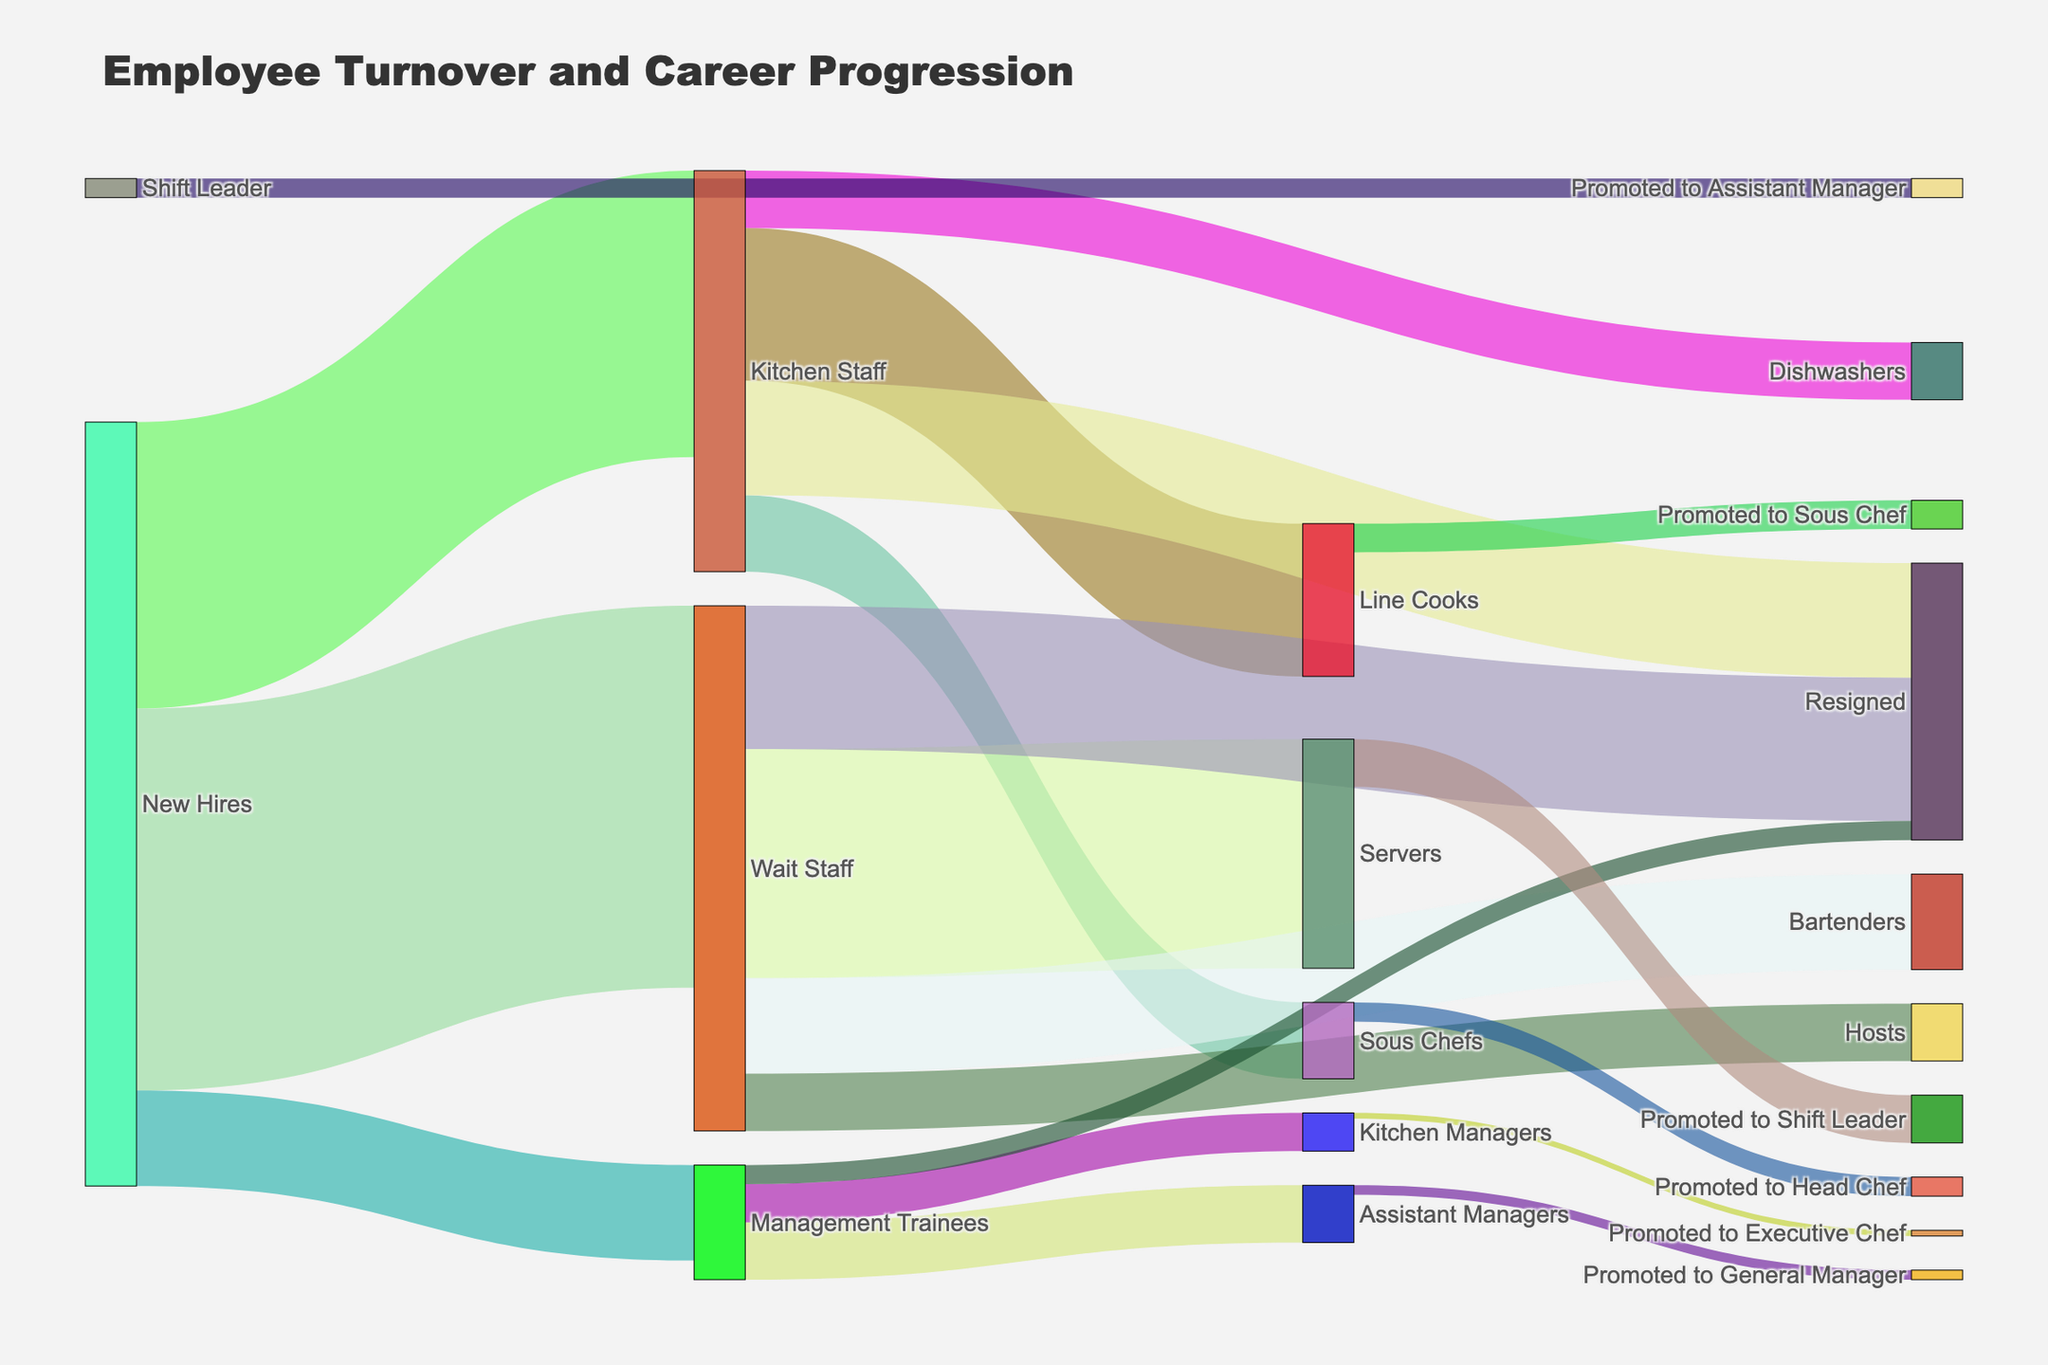what's the title of the figure? The title is displayed at the top of the figure, providing a brief description of what the Sankey diagram represents. Look at the top text for this information.
Answer: Employee Turnover and Career Progression how many new hires become kitchen staff? Look at the starting point 'New Hires' and follow the link to 'Kitchen Staff'. The figure next to this link shows the number of people.
Answer: 150 which category has the highest number of resignations? Sum the resignations from each category: Kitchen Staff (60), Wait Staff (75), and Management Trainees (10). Compare these values to find the highest number.
Answer: Wait Staff how many kitchen staff were promoted to sous chef? Follow the link from 'Kitchen Staff' to 'Sous Chefs' to find the specific number.
Answer: 40 what’s the total number of people who left the organization? Add up the values of the 'Resigned' category from all sources: Kitchen Staff (60), Wait Staff (75), and Management Trainees (10).
Answer: 145 what’s the total number of new hires? Sum the values going from 'New Hires' to various initial roles (Kitchen Staff, Wait Staff, and Management Trainees). Add 150 + 200 + 50.
Answer: 400 which promotion path has the highest flow from the kitchen staff category? Follow the links originating from 'Kitchen Staff' and compare the values to find the highest. Options include Line Cooks (80), Sous Chefs (40), and Dishwashers (30).
Answer: Line Cooks compare the number of servers promoted to shift leaders versus the number of bartenders. Look at the link from 'Servers' to 'Shift Leaders' and compare it to directly linked 'Bartenders'. Servers to Shift Leaders (25) and Bartenders (50).
Answer: Bartenders how many employees advance from line cooks to sous chefs? Trace the link from 'Line Cooks' to 'Promoted to Sous Chef' for this number.
Answer: 15 what’s the total flow from new hires to kitchen managers through management trainees? Follow the links from 'New Hires' -> 'Management Trainees' (50) and then to 'Kitchen Managers' (20). Focus on the path through management trainees.
Answer: 20 